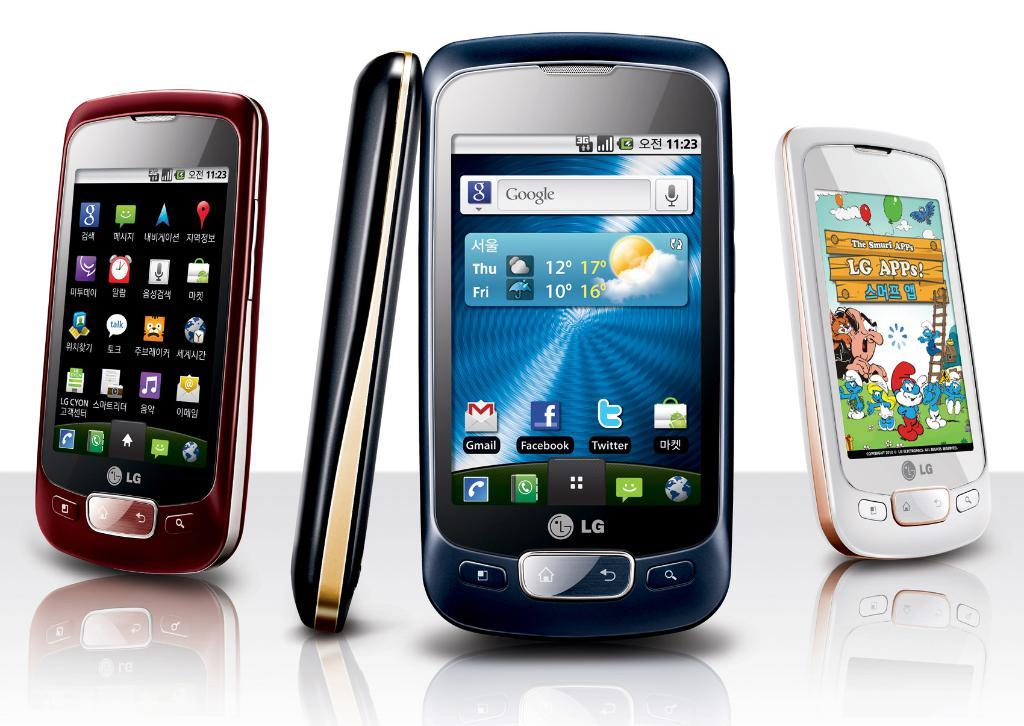Provide a one-sentence caption for the provided image. Three different colors of an LG phone are displayed. 